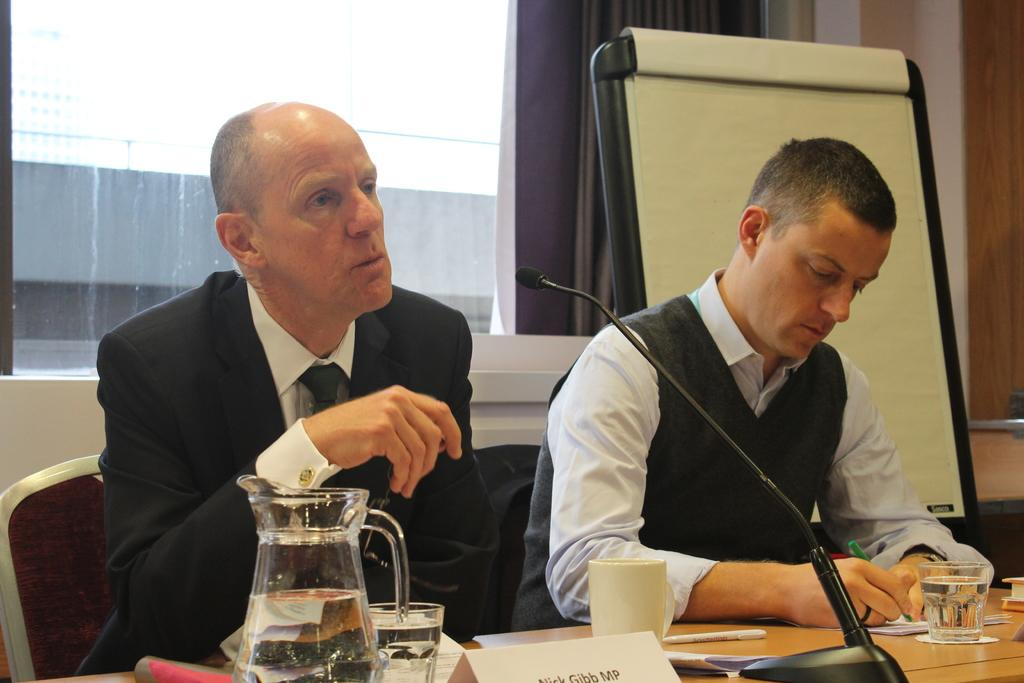How many people are sitting on the chair in the image? There are two persons sitting on a chair in the image. What is present on the table in the image? There is a glass, a jar, a book, and a microphone on the table in the image. What can be seen in the background of the image? There is a window, a curtain, and a board in the background of the image. What type of hope can be seen in the image? There is no reference to hope in the image; it features two people sitting on a chair, a table with various items, and a background with a window, curtain, and board. Is there a church visible in the image? No, there is no church present in the image. 